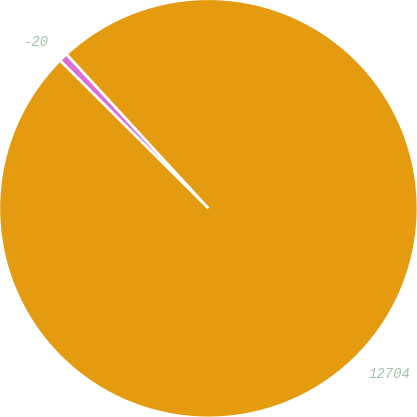<chart> <loc_0><loc_0><loc_500><loc_500><pie_chart><fcel>-20<fcel>12704<nl><fcel>0.69%<fcel>99.31%<nl></chart> 